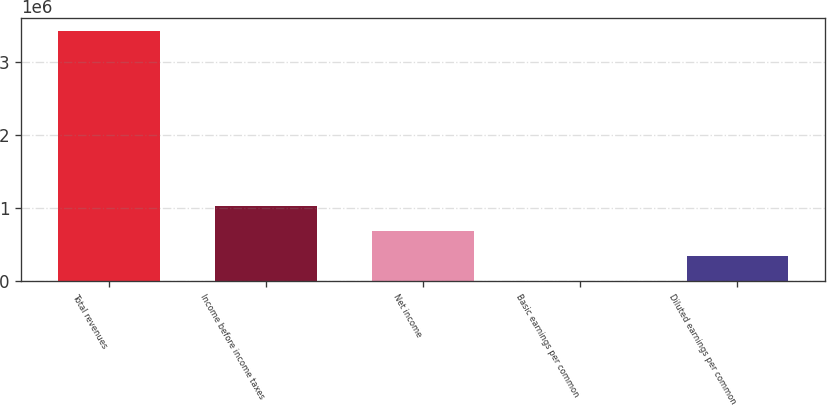Convert chart. <chart><loc_0><loc_0><loc_500><loc_500><bar_chart><fcel>Total revenues<fcel>Income before income taxes<fcel>Net income<fcel>Basic earnings per common<fcel>Diluted earnings per common<nl><fcel>3.43148e+06<fcel>1.02944e+06<fcel>686296<fcel>0.5<fcel>343148<nl></chart> 